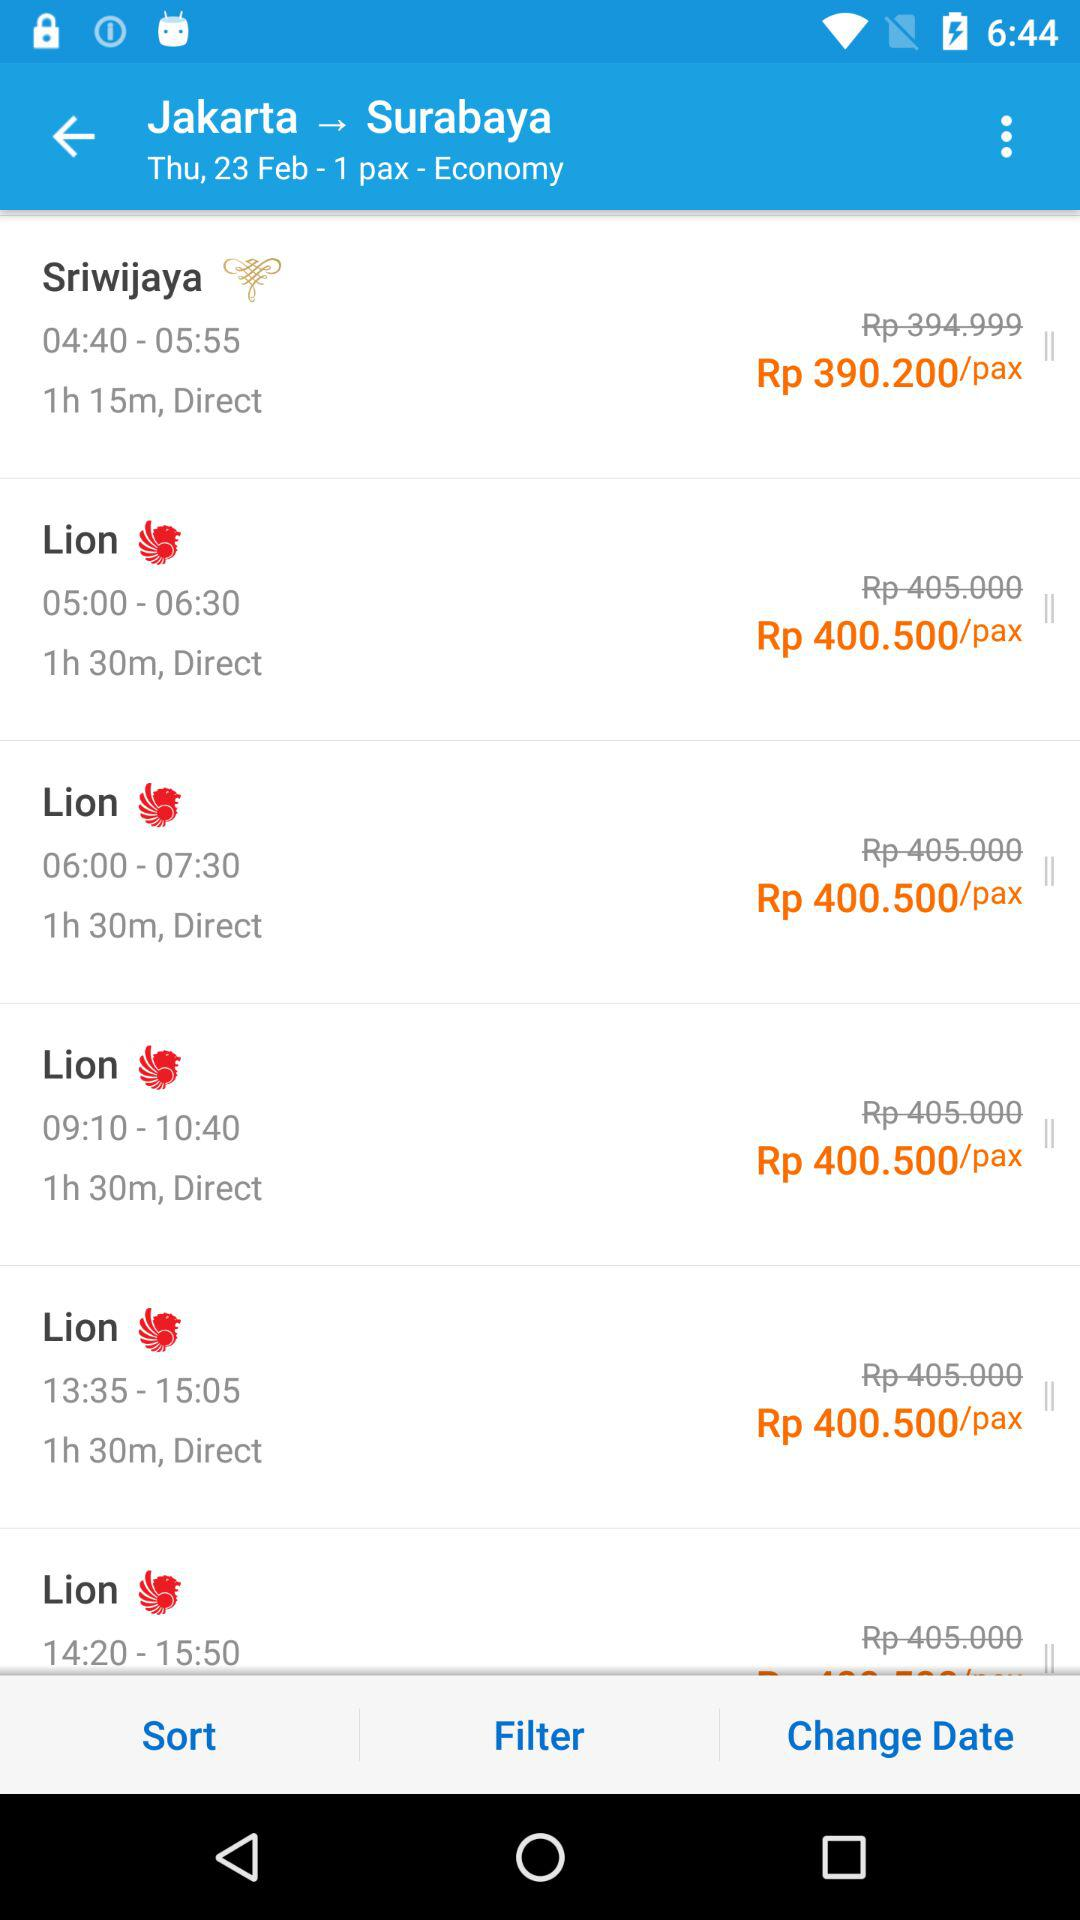What is the origin location? The origin location is Jakarta. 